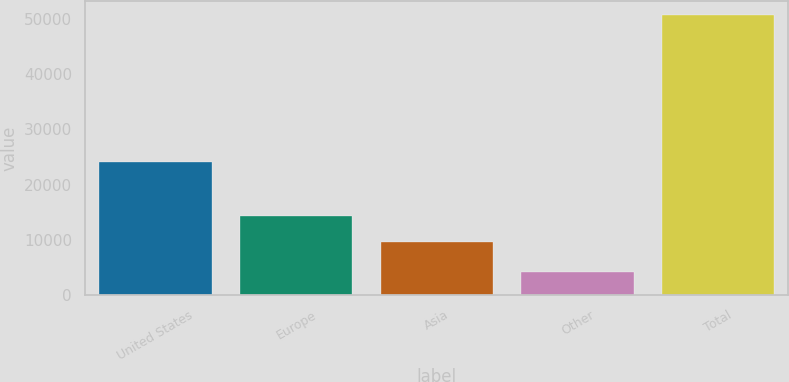Convert chart to OTSL. <chart><loc_0><loc_0><loc_500><loc_500><bar_chart><fcel>United States<fcel>Europe<fcel>Asia<fcel>Other<fcel>Total<nl><fcel>24166<fcel>14342.7<fcel>9703<fcel>4186<fcel>50583<nl></chart> 